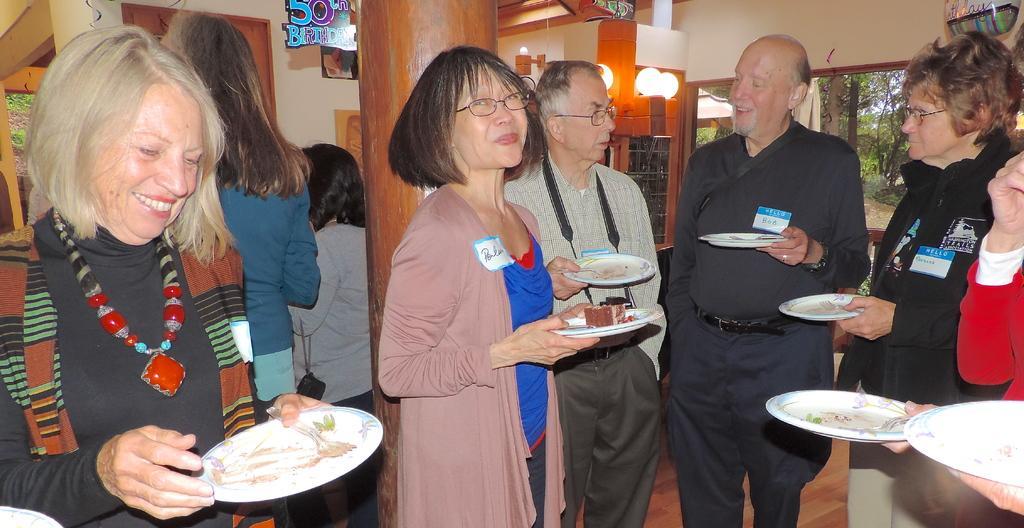Could you give a brief overview of what you see in this image? In this picture there are people on the right and left side of the image and there are windows on the right side of the image, in the background area. 